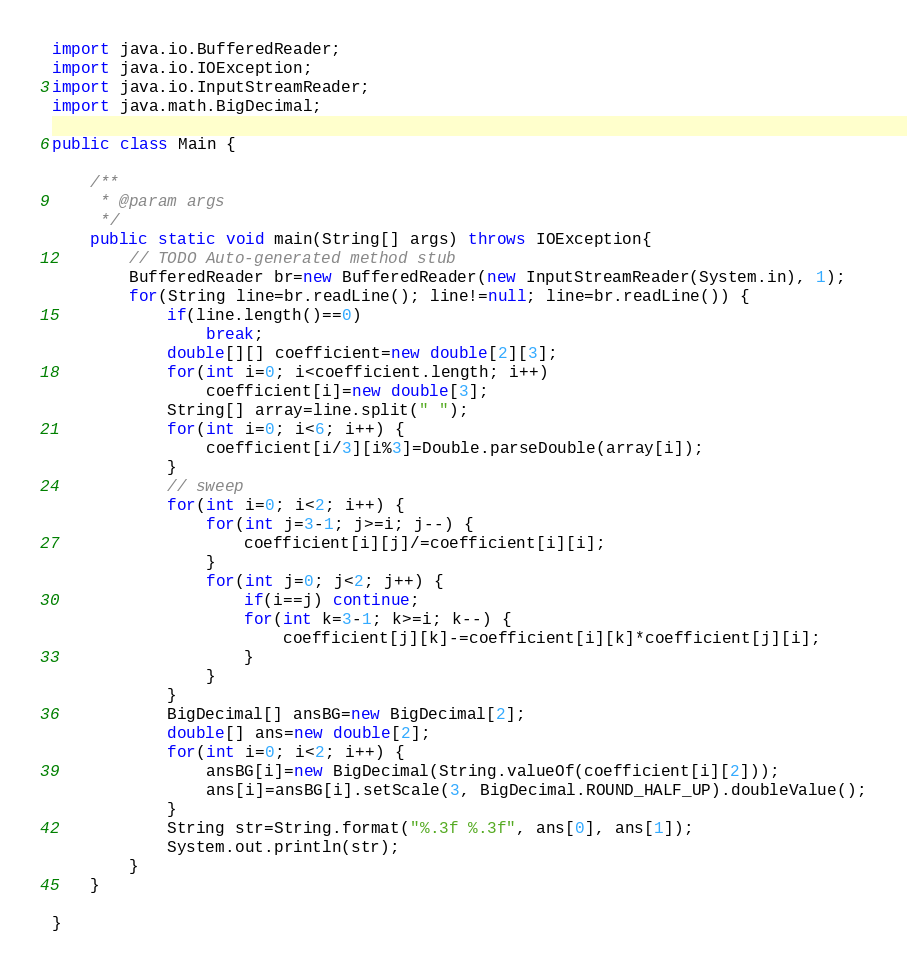Convert code to text. <code><loc_0><loc_0><loc_500><loc_500><_Java_>
import java.io.BufferedReader;
import java.io.IOException;
import java.io.InputStreamReader;
import java.math.BigDecimal;

public class Main {

	/**
	 * @param args
	 */
	public static void main(String[] args) throws IOException{
		// TODO Auto-generated method stub
		BufferedReader br=new BufferedReader(new InputStreamReader(System.in), 1);
		for(String line=br.readLine(); line!=null; line=br.readLine()) {
			if(line.length()==0)
				break;
			double[][] coefficient=new double[2][3];
			for(int i=0; i<coefficient.length; i++)
				coefficient[i]=new double[3];
			String[] array=line.split(" ");
			for(int i=0; i<6; i++) {
				coefficient[i/3][i%3]=Double.parseDouble(array[i]);
			}
			// sweep
			for(int i=0; i<2; i++) {
				for(int j=3-1; j>=i; j--) {
					coefficient[i][j]/=coefficient[i][i];
				}
				for(int j=0; j<2; j++) {
					if(i==j) continue;
					for(int k=3-1; k>=i; k--) {
						coefficient[j][k]-=coefficient[i][k]*coefficient[j][i];
					}
				}
			}
			BigDecimal[] ansBG=new BigDecimal[2];
			double[] ans=new double[2];
			for(int i=0; i<2; i++) {
				ansBG[i]=new BigDecimal(String.valueOf(coefficient[i][2]));
				ans[i]=ansBG[i].setScale(3, BigDecimal.ROUND_HALF_UP).doubleValue();
			}
			String str=String.format("%.3f %.3f", ans[0], ans[1]);
			System.out.println(str);
		}
	}

}</code> 